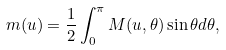Convert formula to latex. <formula><loc_0><loc_0><loc_500><loc_500>m ( u ) = \frac { 1 } { 2 } \int ^ { \pi } _ { 0 } M ( u , \theta ) \sin \theta d \theta ,</formula> 